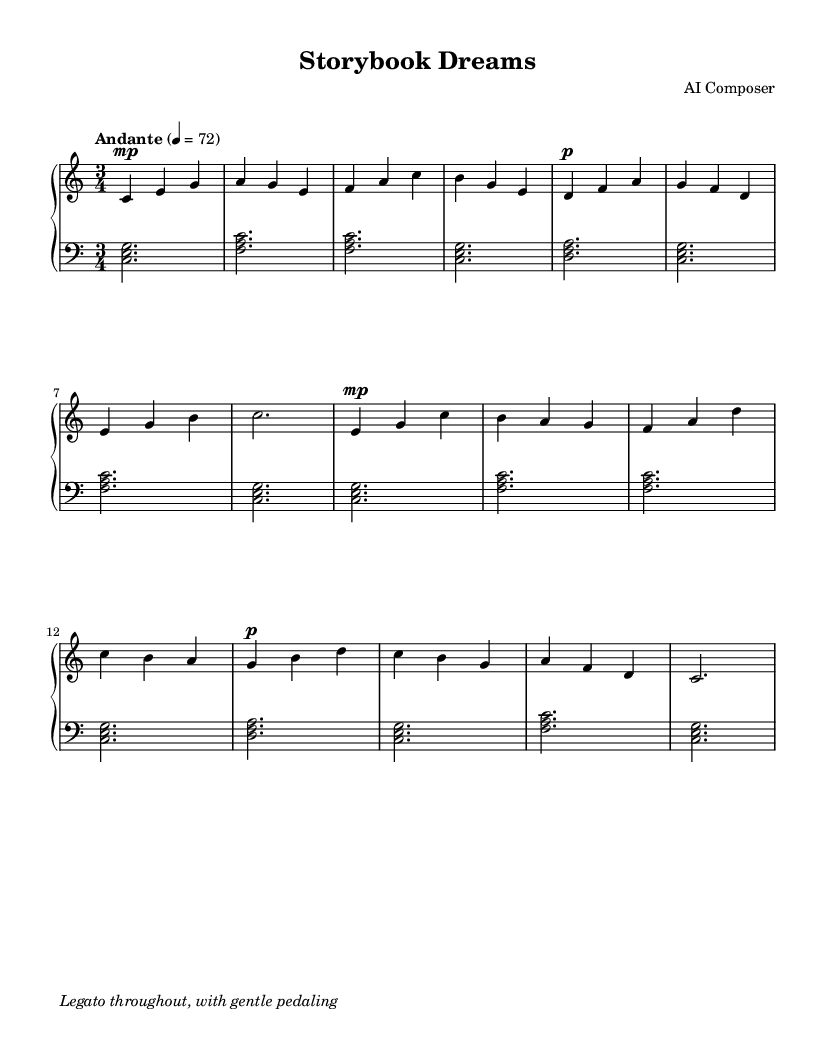What is the key signature of this music? The key signature is C major, which has no sharps or flats.
Answer: C major What is the time signature of the music? The time signature is indicated as 3/4, meaning there are three beats in each measure and the quarter note gets one beat.
Answer: 3/4 What is the tempo marking for this piece? The tempo marking is labeled "Andante," which suggests a moderate speed, typically around 76 to 108 beats per minute.
Answer: Andante How many measures are in the upper staff? By counting the measures in the upper staff section of the score, there is a total of 8 measures present, as each line typically ends with a bar line.
Answer: 8 What dynamic marking is indicated in the first measure? The first measure shows a dynamic marking of "mp" which stands for "mezzo-piano," indicating a moderately soft volume.
Answer: mp Which instrument is primarily featured in this score? The score is specifically for piano, as indicated by the label "PianoStaff" and the clefs used for the upper and lower staves.
Answer: Piano What kind of articulations are suggested throughout the piece? The music suggests a legato style throughout, which means that the notes should be played smoothly and connected without interruption.
Answer: Legato 